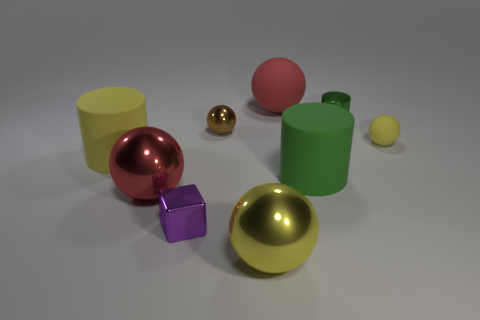There is a metal ball that is in front of the large shiny ball on the left side of the big object that is in front of the red metal sphere; what size is it?
Provide a short and direct response. Large. How many other objects are there of the same material as the brown object?
Provide a succinct answer. 4. There is a red thing that is left of the tiny purple block; what is its size?
Your answer should be very brief. Large. What number of objects are right of the yellow cylinder and on the left side of the purple object?
Ensure brevity in your answer.  1. What material is the large object that is behind the yellow sphere that is on the right side of the yellow shiny ball made of?
Your answer should be compact. Rubber. What is the material of the other small object that is the same shape as the small brown thing?
Your response must be concise. Rubber. Are there any tiny yellow objects?
Your answer should be compact. Yes. What shape is the tiny green object that is the same material as the tiny block?
Your response must be concise. Cylinder. What is the material of the yellow thing that is in front of the purple thing?
Give a very brief answer. Metal. There is a matte object that is behind the tiny yellow matte ball; does it have the same color as the tiny metallic cube?
Offer a very short reply. No. 